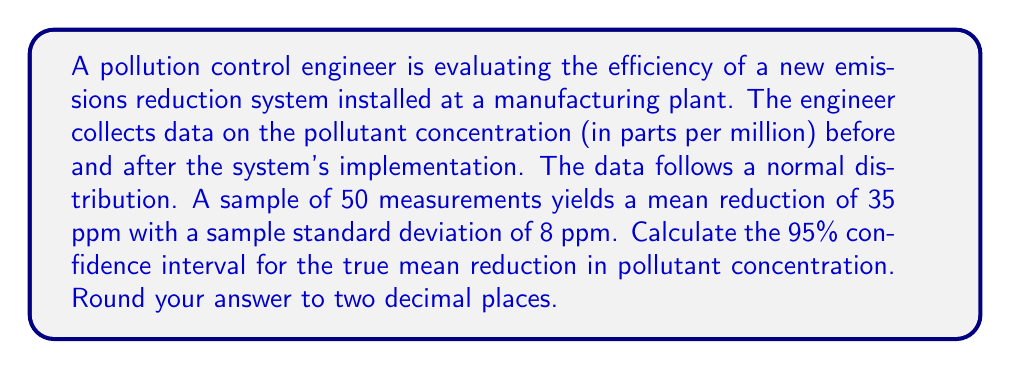Teach me how to tackle this problem. To calculate the confidence interval for the true mean reduction, we'll use the formula:

$$ \text{CI} = \bar{x} \pm t_{\alpha/2, n-1} \cdot \frac{s}{\sqrt{n}} $$

Where:
- $\bar{x}$ is the sample mean
- $t_{\alpha/2, n-1}$ is the t-value for a 95% confidence level with n-1 degrees of freedom
- $s$ is the sample standard deviation
- $n$ is the sample size

Given:
- Sample mean $\bar{x} = 35$ ppm
- Sample standard deviation $s = 8$ ppm
- Sample size $n = 50$
- Confidence level = 95%

Steps:
1. Find the t-value:
   For a 95% confidence level and 49 degrees of freedom (n-1 = 50-1 = 49),
   $t_{0.025, 49} \approx 2.01$ (from t-distribution table)

2. Calculate the margin of error:
   $$ \text{Margin of Error} = t_{\alpha/2, n-1} \cdot \frac{s}{\sqrt{n}} = 2.01 \cdot \frac{8}{\sqrt{50}} \approx 2.27 $$

3. Calculate the confidence interval:
   $$ \text{CI} = 35 \pm 2.27 $$
   $$ \text{Lower bound} = 35 - 2.27 = 32.73 $$
   $$ \text{Upper bound} = 35 + 2.27 = 37.27 $$

4. Round to two decimal places:
   Lower bound: 32.73
   Upper bound: 37.27
Answer: The 95% confidence interval for the true mean reduction in pollutant concentration is (32.73 ppm, 37.27 ppm). 